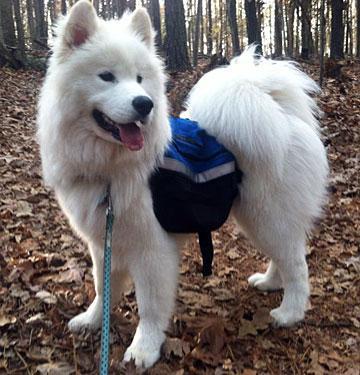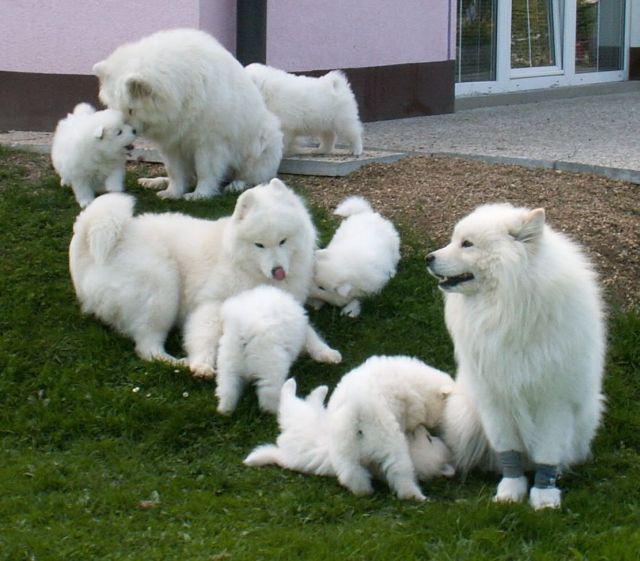The first image is the image on the left, the second image is the image on the right. Assess this claim about the two images: "A dog is on a wooden floor.". Correct or not? Answer yes or no. No. The first image is the image on the left, the second image is the image on the right. Examine the images to the left and right. Is the description "a dog is indoors on a wooden floor" accurate? Answer yes or no. No. 